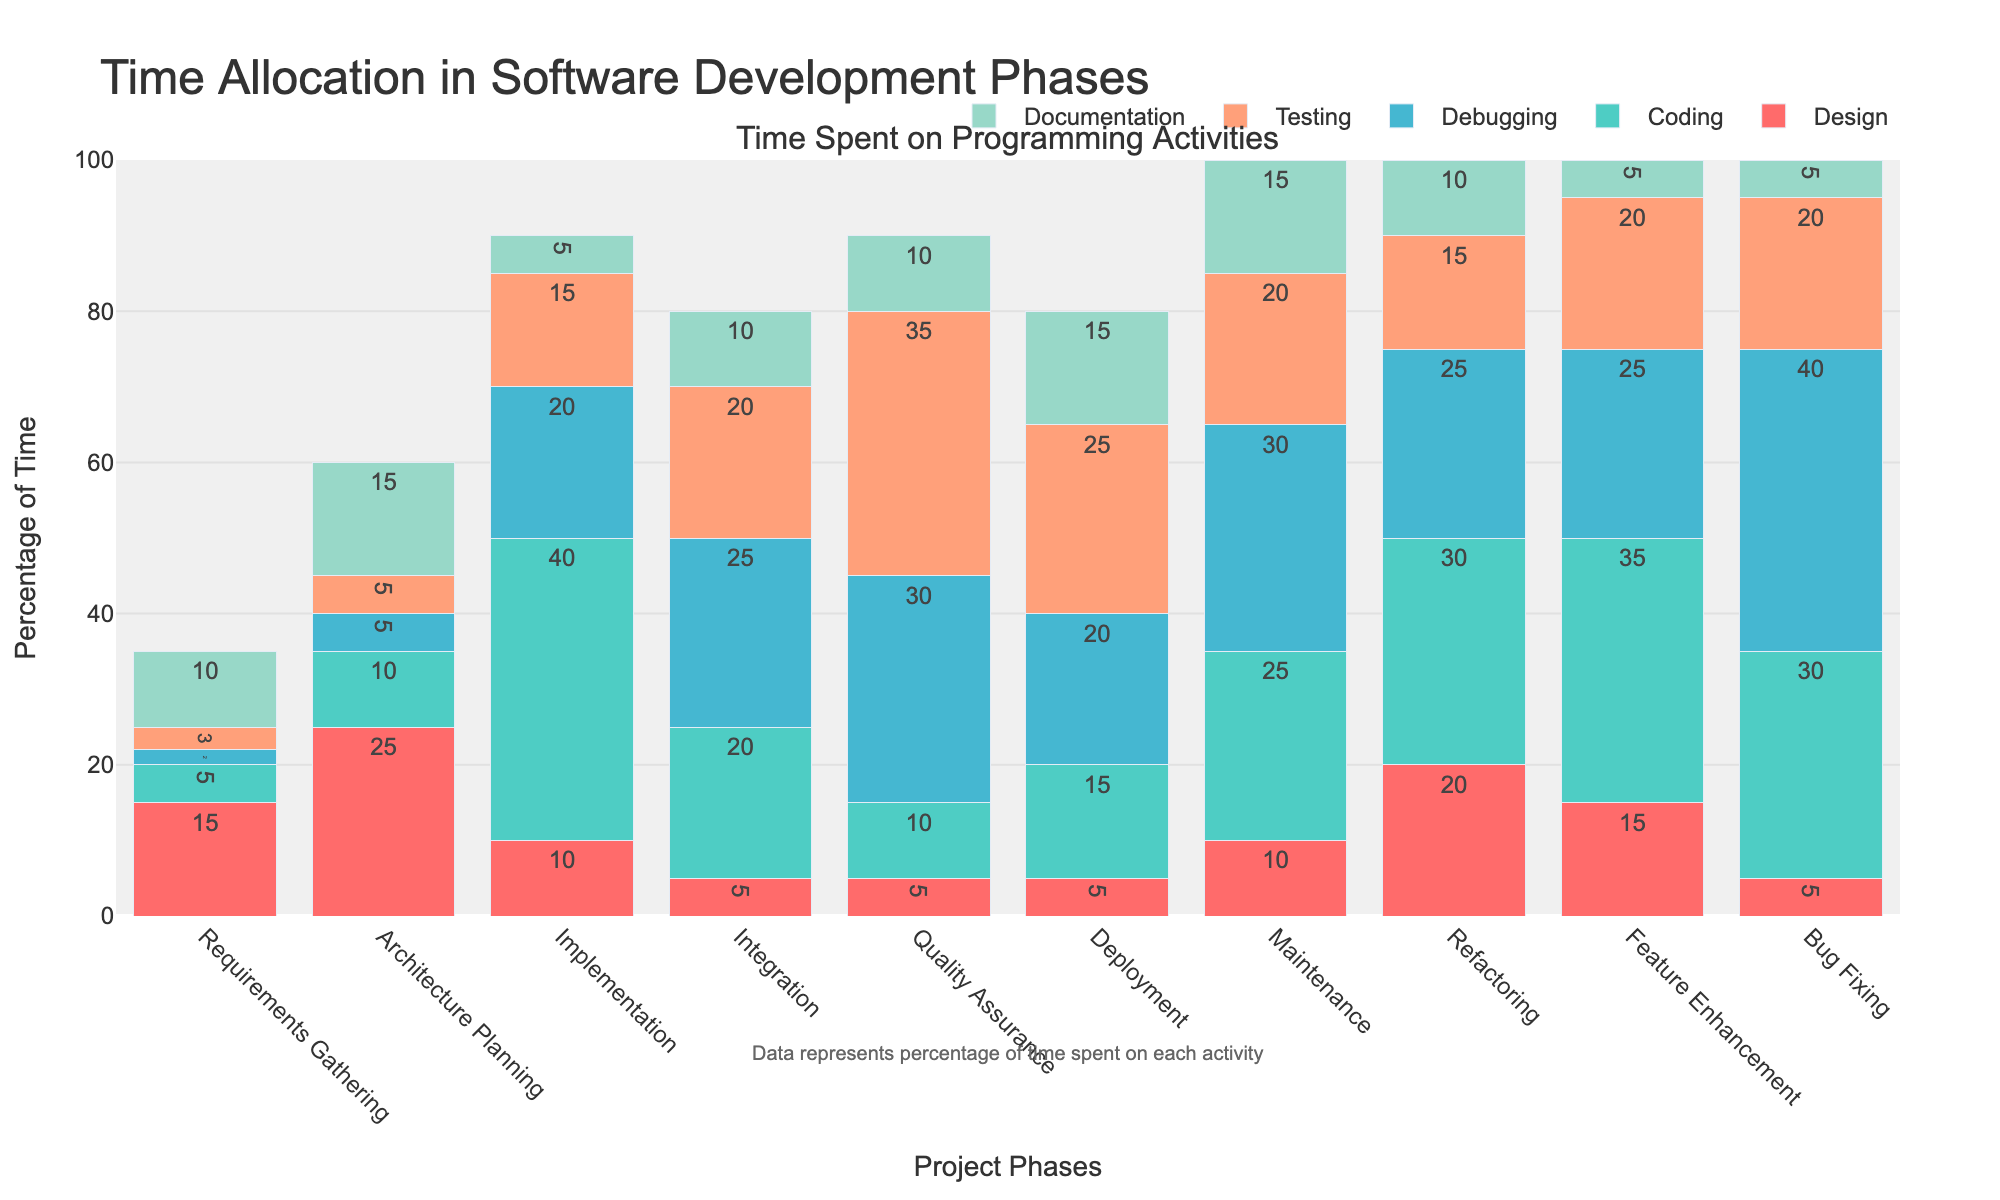What's the project phase with the highest percentage of time spent on testing? Look at the 'Testing' bar in each project phase and find the tallest one. The tallest bar is in the 'Quality Assurance' phase.
Answer: Quality Assurance In which project phase is the combined time spent on Coding and Debugging the highest? Sum the values for Coding and Debugging in each phase, and identify the phase with the maximum total. The highest combined total is during the 'Implementation' phase (40 + 20 = 60).
Answer: Implementation How much more time is spent on Documentation during Deployment compared to Feature Enhancement? Subtract the time spent on Documentation in 'Feature Enhancement' from the time spent in 'Deployment' (15 - 5 = 10).
Answer: 10% During which phase is the least time spent on Design? Find the lowest value in the 'Design' bar across all phases, which is during the 'Integration' and 'Deployment' phases (both 5%).
Answer: Integration and Deployment What is the average time spent on Debugging across all project phases? Sum the values for Debugging across all phases and divide by the number of phases (2 + 5 + 20 + 25 + 30 + 20 + 30 + 25 + 25 + 40 = 222; 222 / 10 = 22.2).
Answer: 22.2% Which activity has the highest percentage of time spent in the 'Maintenance' phase? Look at the values for all activities in the 'Maintenance' phase and identify the highest one, which is Debugging (30%).
Answer: Debugging Compare the time spent on Coding in 'Implementation' phase to 'Feature Enhancement'. How much more time is spent? Subtract the time spent on Coding in 'Feature Enhancement' from the time spent in 'Implementation' (40 - 35 = 5).
Answer: 5% What is the total percentage of time spent on Testing across all phases? Sum the values for Testing across all project phases (3 + 5 + 15 + 20 + 35 + 25 + 20 + 15 + 20 + 20 = 178).
Answer: 178% In which phase is the time spent on Design and Documentation equal? Find the phase where the values for Design and Documentation are the same, which occurs in 'Refactoring' (both 20).
Answer: Refactoring How much time on average is spent on Architecture Planning for Design and Coding combined? Sum the values for Design and Coding during 'Architecture Planning' and divide by 2 ((25 + 10) / 2 = 17.5).
Answer: 17.5% 